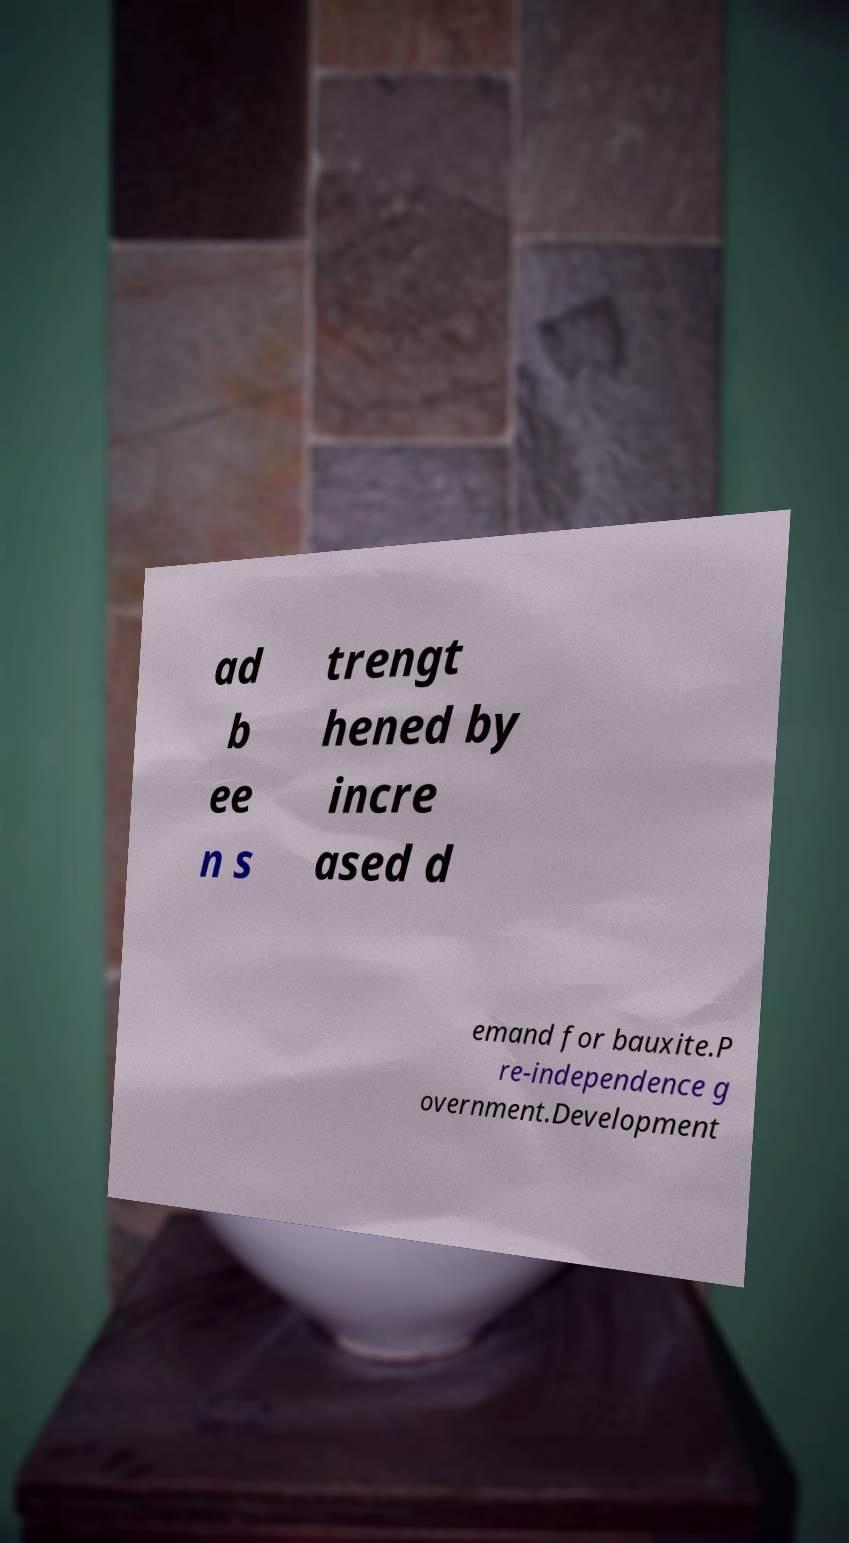There's text embedded in this image that I need extracted. Can you transcribe it verbatim? ad b ee n s trengt hened by incre ased d emand for bauxite.P re-independence g overnment.Development 